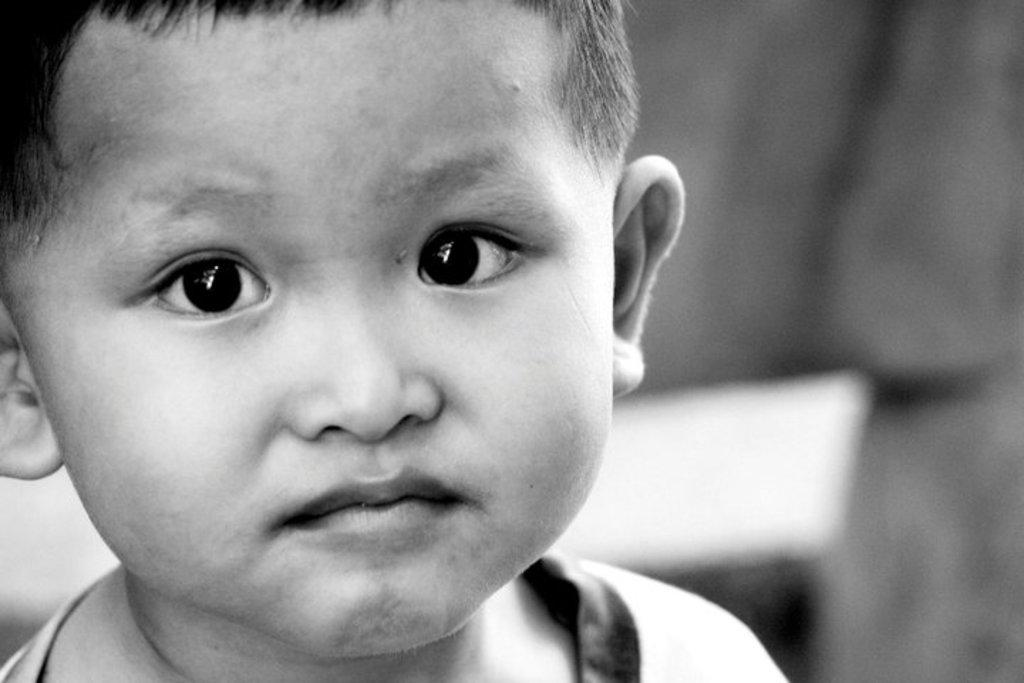What is the main subject of the image? The main subject of the image is a kid. What is the kid doing in the image? The kid is watching. What type of growth can be seen on the road in the image? There is no road or growth present in the image; it only features a kid who is watching. 